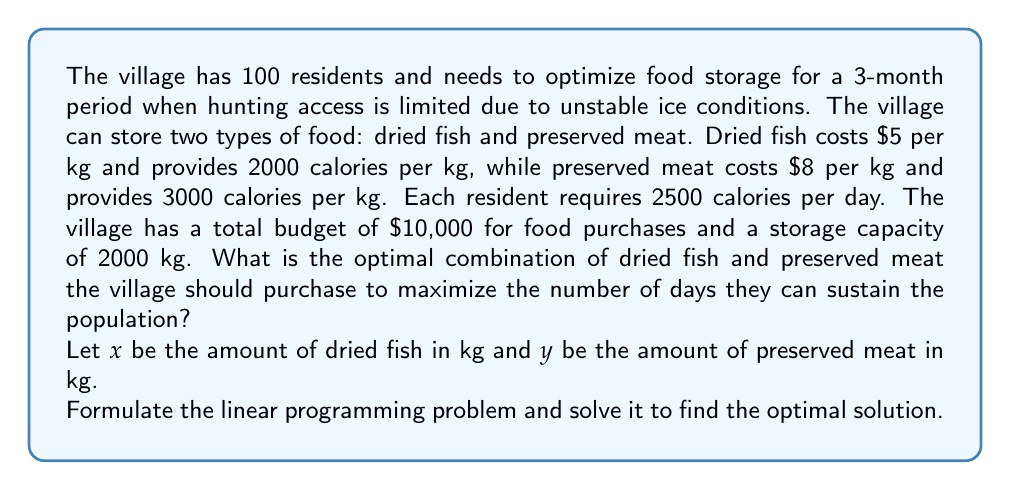Could you help me with this problem? To solve this problem, we need to set up a linear programming model and then solve it. Let's break it down step-by-step:

1. Define the objective function:
We want to maximize the number of days the village can be sustained. Let's call this $D$.

$$D = \frac{2000x + 3000y}{100 \cdot 2500}$$

The numerator represents the total calories from both food sources, and the denominator is the daily caloric need for the entire village.

2. Set up the constraints:

a) Budget constraint:
$$5x + 8y \leq 10000$$

b) Storage capacity constraint:
$$x + y \leq 2000$$

c) Non-negativity constraints:
$$x \geq 0, y \geq 0$$

3. Simplify the objective function:
$$D = \frac{4x + 6y}{500}$$

4. Rewrite the problem in standard form:

Maximize: $Z = 4x + 6y$
Subject to:
$$5x + 8y \leq 10000$$
$$x + y \leq 2000$$
$$x, y \geq 0$$

5. Solve using the graphical method or simplex algorithm:

The feasible region is bounded by the two constraint lines and the non-negativity constraints. The optimal solution will be at one of the corner points of this region.

The corner points are:
(0, 0), (2000, 0), (0, 1250), and the intersection of the two constraint lines.

To find the intersection, solve:
$$5x + 8y = 10000$$
$$x + y = 2000$$

Subtracting the second equation from the first:
$$4x + 7y = 8000$$
$$x + y = 2000$$
$$3x + 6y = 6000$$
$$x + 2y = 2000$$
$$x = 2000 - 2y$$

Substituting into the first equation:
$$5(2000 - 2y) + 8y = 10000$$
$$10000 - 10y + 8y = 10000$$
$$-2y = 0$$
$$y = 0$$
$$x = 2000$$

So, the intersection point is (2000, 0), which is already one of our corner points.

Evaluating Z at each corner point:
(0, 0): Z = 0
(2000, 0): Z = 8000
(0, 1250): Z = 7500

The maximum value of Z occurs at (2000, 0), which corresponds to purchasing 2000 kg of dried fish and 0 kg of preserved meat.

6. Calculate the number of days:
$$D = \frac{4(2000) + 6(0)}{500} = 16$$
Answer: The optimal solution is to purchase 2000 kg of dried fish and 0 kg of preserved meat. This will sustain the village for 16 days. 